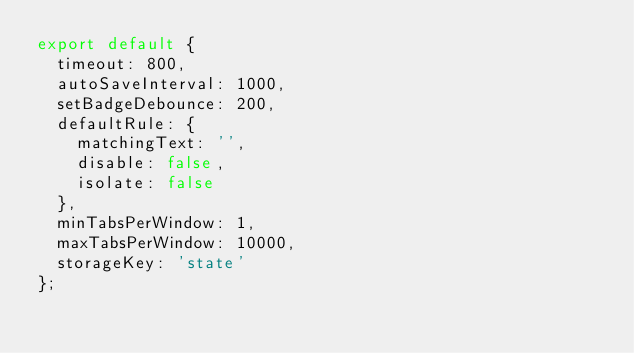Convert code to text. <code><loc_0><loc_0><loc_500><loc_500><_JavaScript_>export default {
  timeout: 800,
  autoSaveInterval: 1000,
  setBadgeDebounce: 200,
  defaultRule: {
    matchingText: '',
    disable: false,
    isolate: false
  },
  minTabsPerWindow: 1,
  maxTabsPerWindow: 10000,
  storageKey: 'state'
};
</code> 